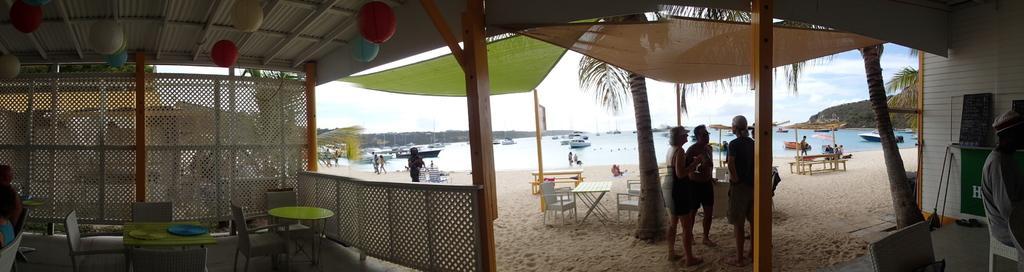Please provide a concise description of this image. In this image I see number of chairs and tables and I can also see few people who are standing and sitting, I can also see the sand, water, few boats and the trees and the decoration over here. 